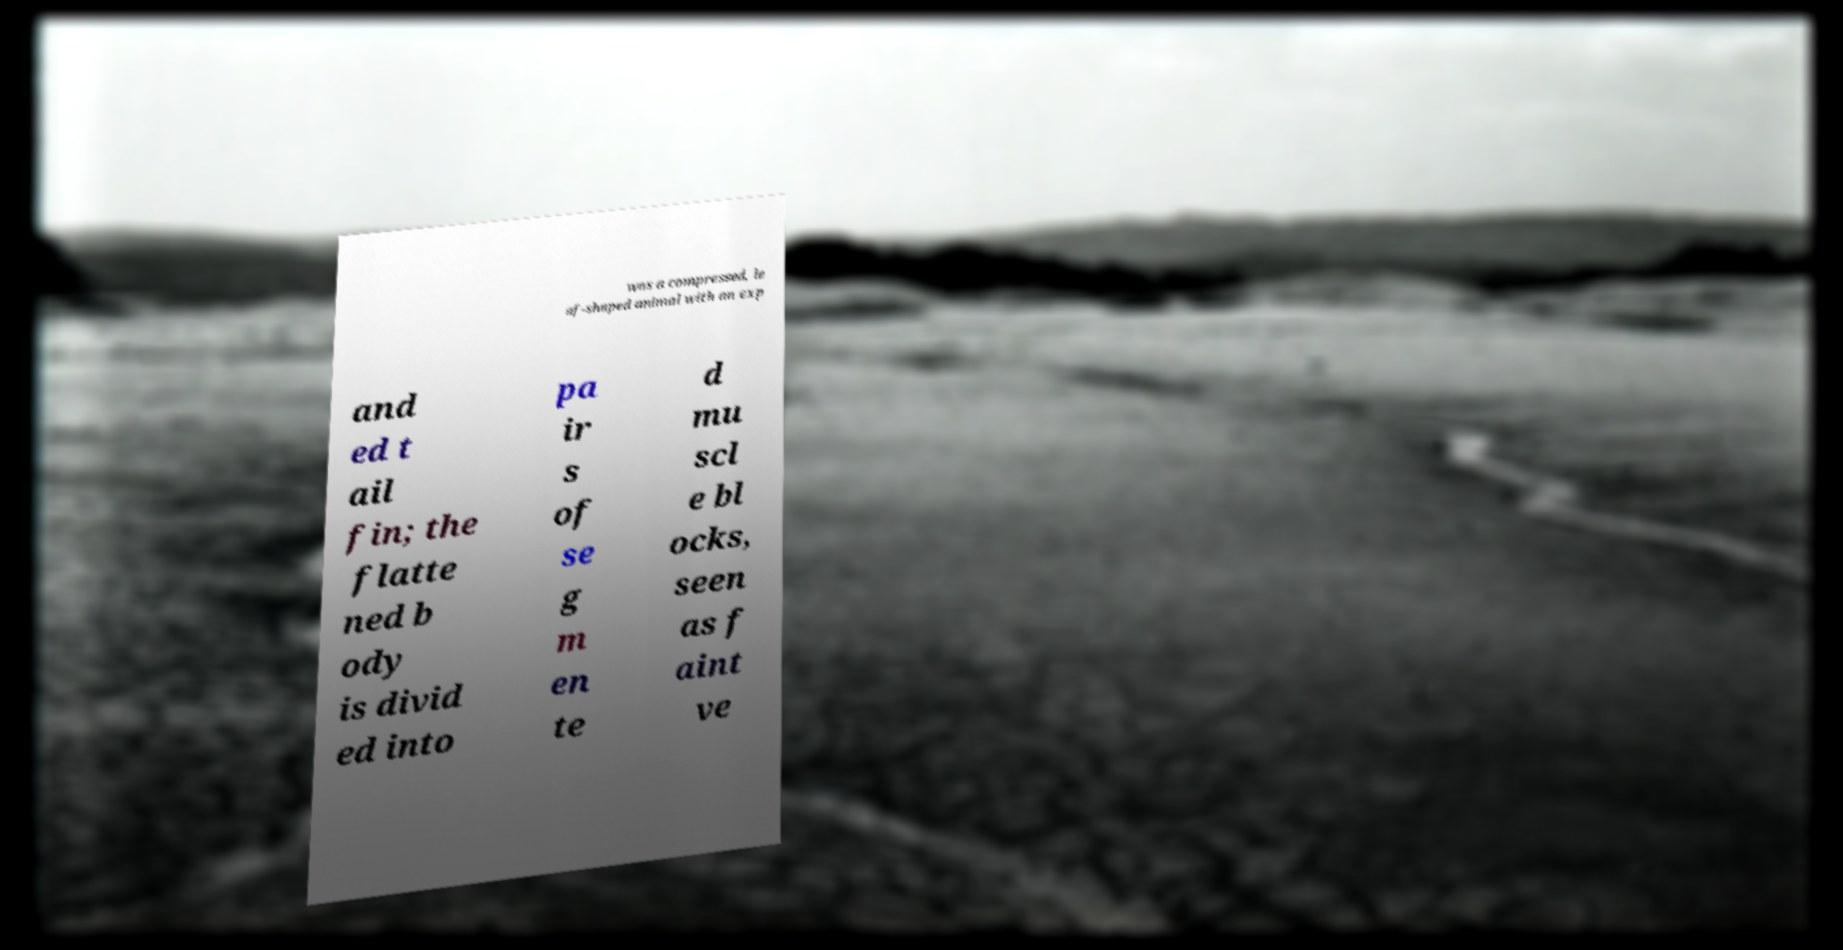Could you extract and type out the text from this image? was a compressed, le af-shaped animal with an exp and ed t ail fin; the flatte ned b ody is divid ed into pa ir s of se g m en te d mu scl e bl ocks, seen as f aint ve 